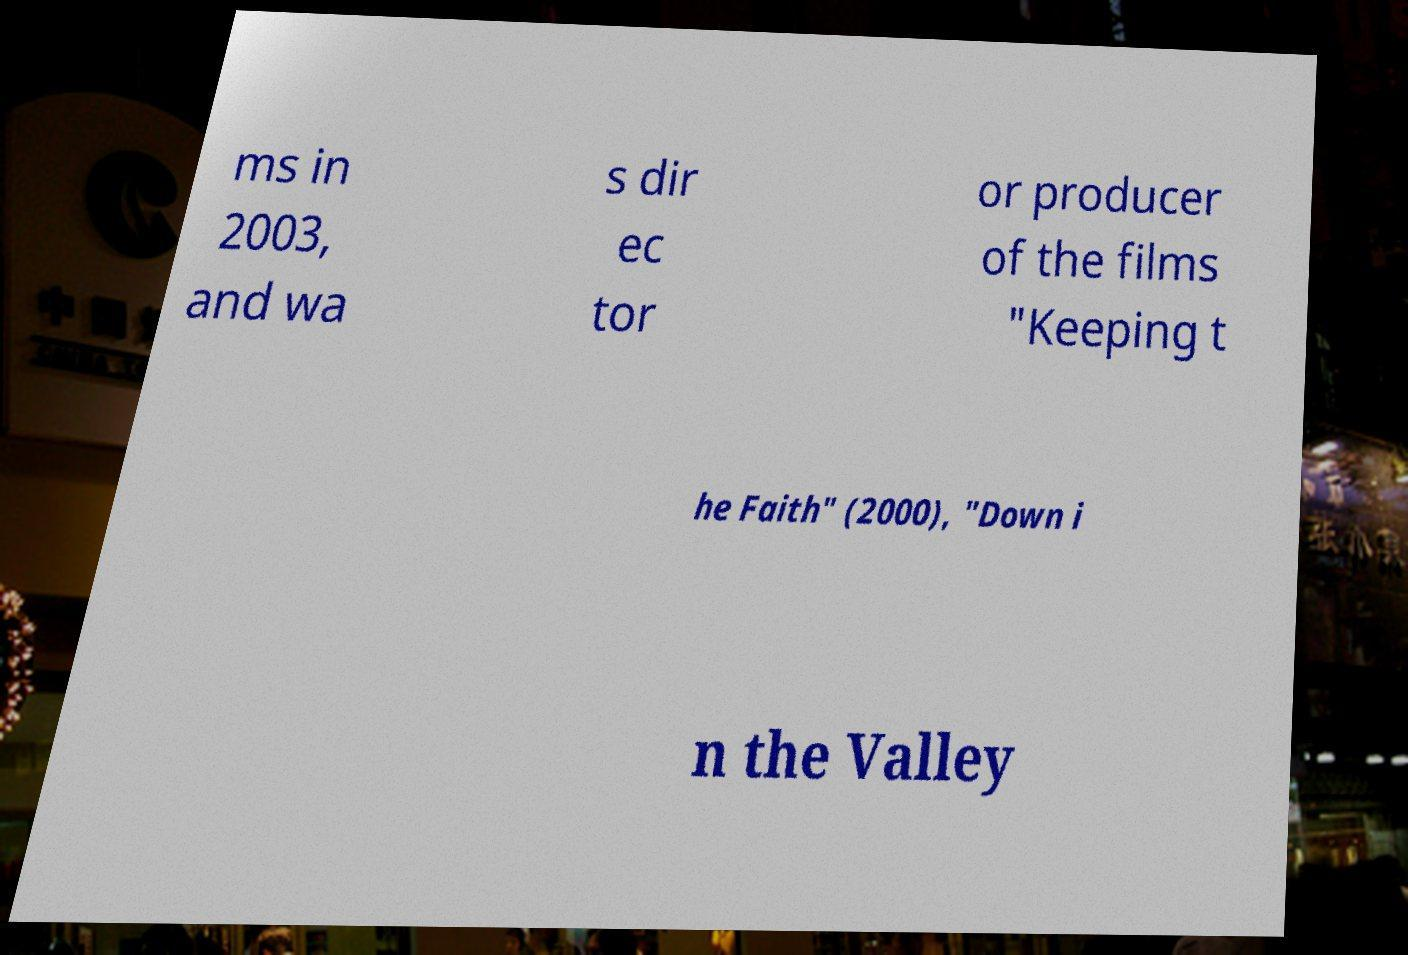For documentation purposes, I need the text within this image transcribed. Could you provide that? ms in 2003, and wa s dir ec tor or producer of the films "Keeping t he Faith" (2000), "Down i n the Valley 